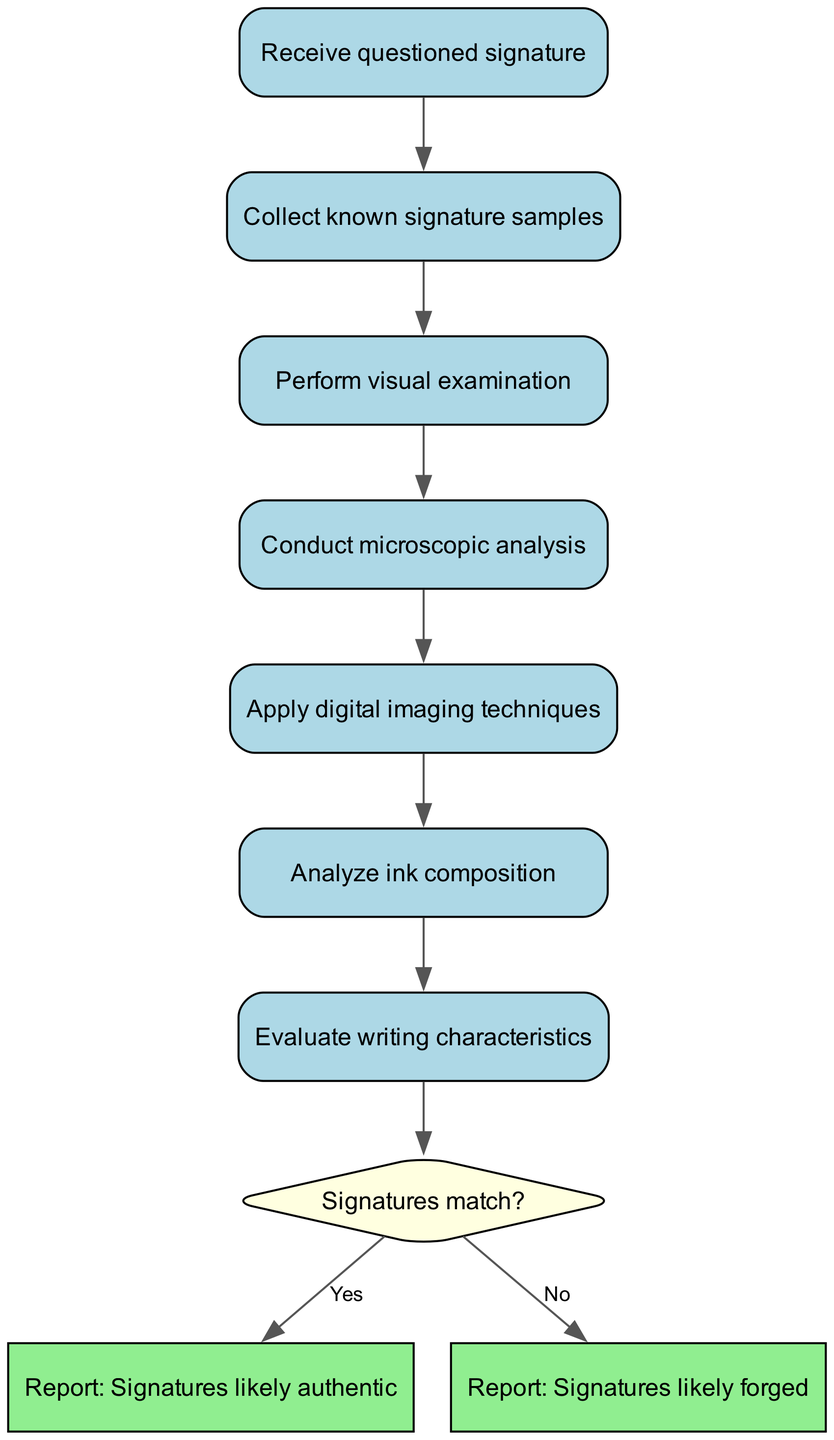What is the starting point of the workflow? The starting point of the workflow is defined as "Receive questioned signature," indicating the initiation of the analysis process.
Answer: Receive questioned signature How many steps are there in the analysis process? Counting the nodes labeled from "Collect known signature samples" to "Evaluate writing characteristics" sequentially reveals a total of six steps before reaching the decision node.
Answer: Six What technique follows microscopic analysis in the workflow? The flowchart shows that after "Conduct microscopic analysis," the next step is "Apply digital imaging techniques."
Answer: Apply digital imaging techniques What decision is made at the end of the analysis? The final decision made in the workflow is whether the signatures match, leading to one of two reporting outcomes.
Answer: Signatures match? What is the output if the signatures match? If the analysis concludes that the signatures match, the output report states that the signatures are likely authentic.
Answer: Report: Signatures likely authentic Which technique is used to analyze the ink composition? The workflow indicates that "Analyze ink composition" is a specific step where the ink properties are examined.
Answer: Analyze ink composition What step comes after performing a visual examination? Following the "Perform visual examination," the workflow shows that the next step is to "Conduct microscopic analysis."
Answer: Conduct microscopic analysis What color represents the decision node in the diagram? The decision node is highlighted in light yellow, distinguishing it from other process steps in the flowchart.
Answer: Light yellow How does one reach the conclusion that signatures are likely forged? If the decision node indicates that the signatures do not match, the process flows to the endpoint stating that the signatures are likely forged.
Answer: Report: Signatures likely forged 